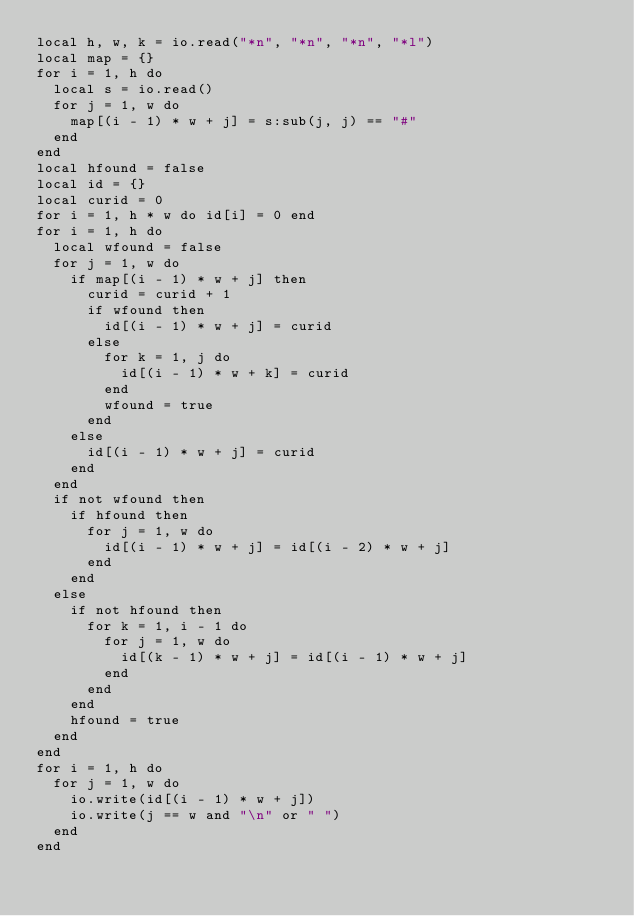<code> <loc_0><loc_0><loc_500><loc_500><_Lua_>local h, w, k = io.read("*n", "*n", "*n", "*l")
local map = {}
for i = 1, h do
  local s = io.read()
  for j = 1, w do
    map[(i - 1) * w + j] = s:sub(j, j) == "#"
  end
end
local hfound = false
local id = {}
local curid = 0
for i = 1, h * w do id[i] = 0 end
for i = 1, h do
  local wfound = false
  for j = 1, w do
    if map[(i - 1) * w + j] then
      curid = curid + 1
      if wfound then
        id[(i - 1) * w + j] = curid
      else
        for k = 1, j do
          id[(i - 1) * w + k] = curid
        end
        wfound = true
      end
    else
      id[(i - 1) * w + j] = curid
    end
  end
  if not wfound then
    if hfound then
      for j = 1, w do
        id[(i - 1) * w + j] = id[(i - 2) * w + j]
      end
    end
  else
    if not hfound then
      for k = 1, i - 1 do
        for j = 1, w do
          id[(k - 1) * w + j] = id[(i - 1) * w + j]
        end
      end
    end
    hfound = true
  end
end
for i = 1, h do
  for j = 1, w do
    io.write(id[(i - 1) * w + j])
    io.write(j == w and "\n" or " ")
  end
end
</code> 